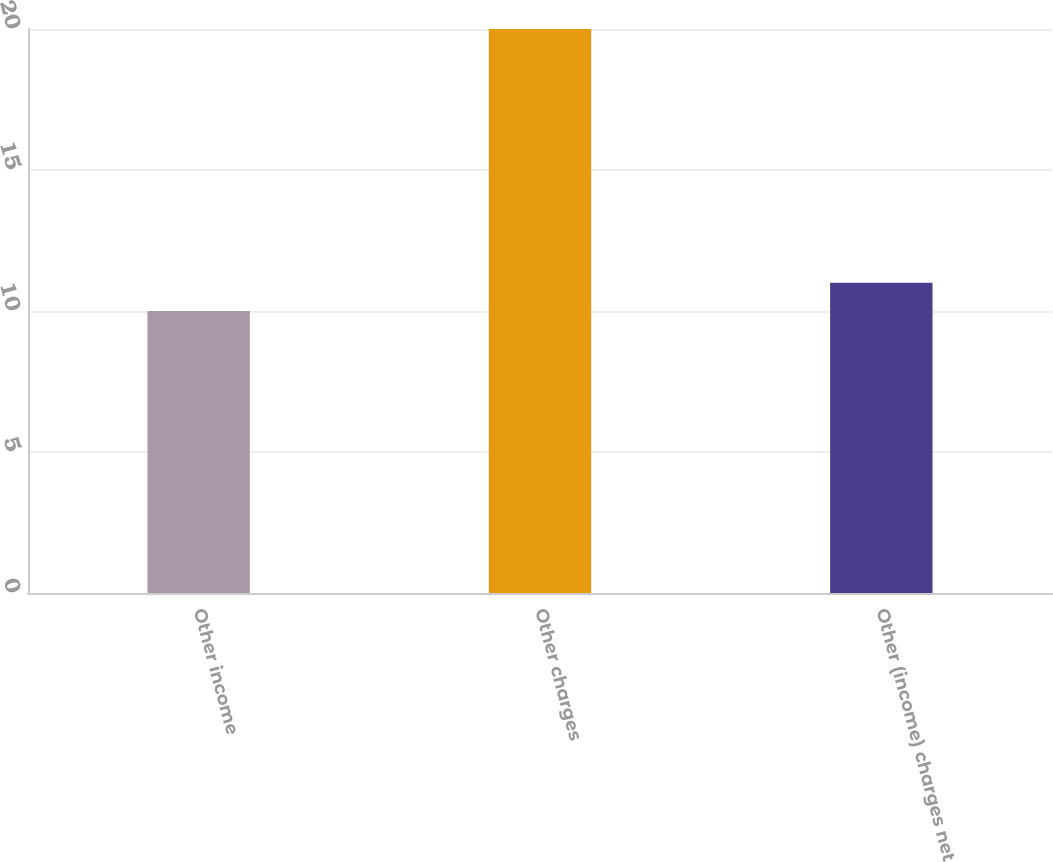Convert chart. <chart><loc_0><loc_0><loc_500><loc_500><bar_chart><fcel>Other income<fcel>Other charges<fcel>Other (income) charges net<nl><fcel>10<fcel>20<fcel>11<nl></chart> 